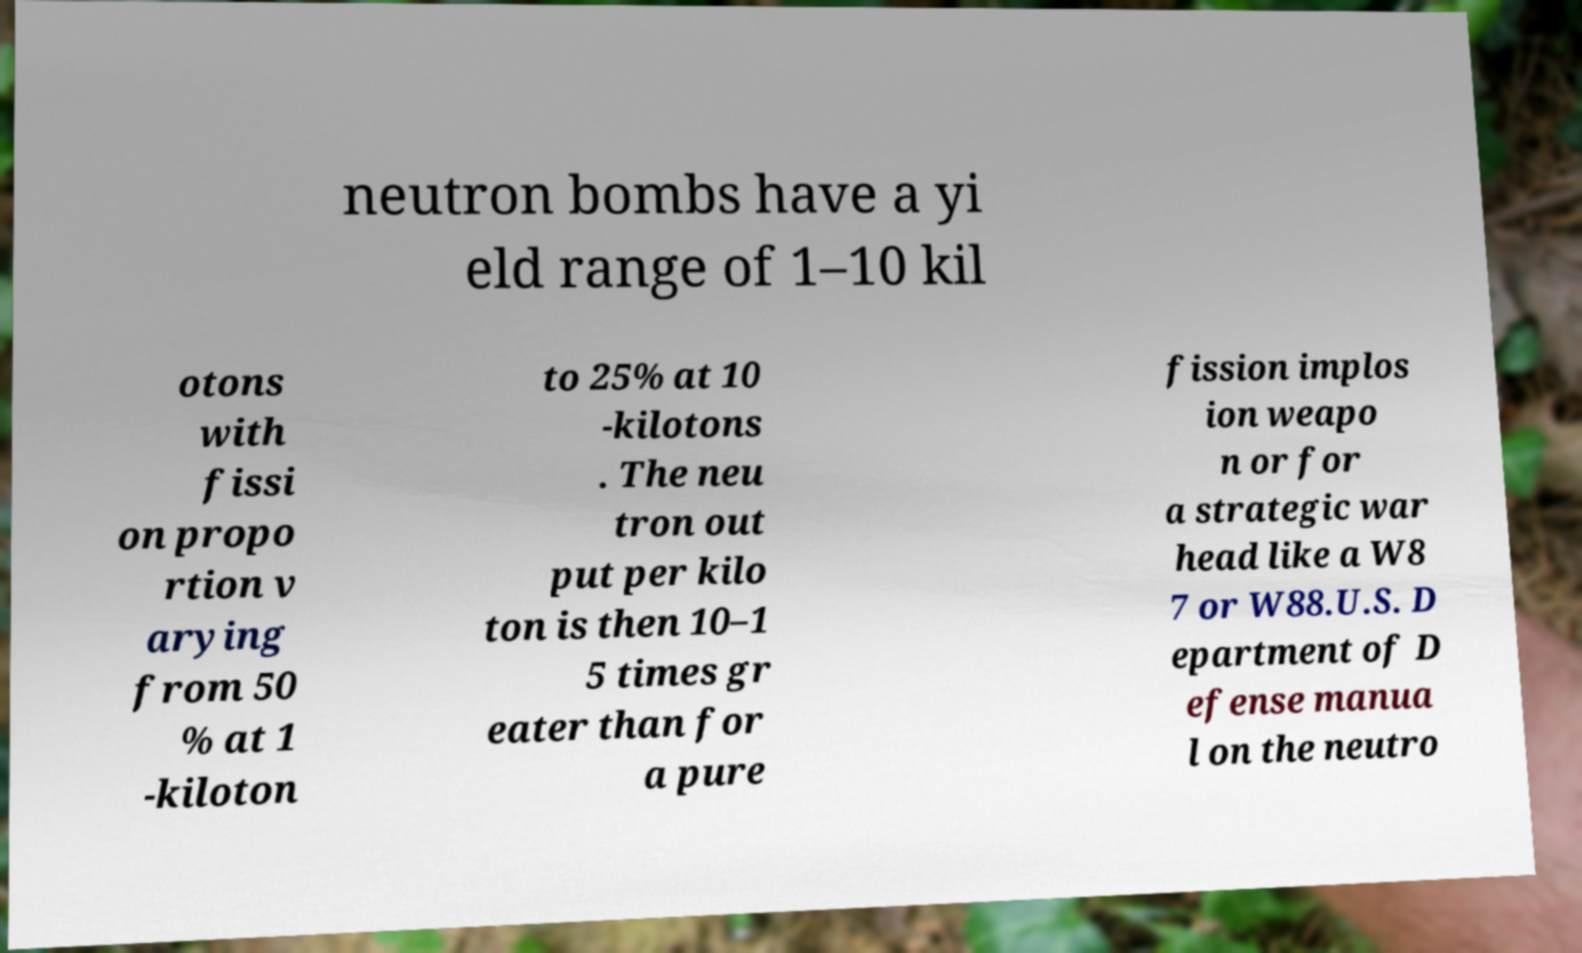Can you read and provide the text displayed in the image?This photo seems to have some interesting text. Can you extract and type it out for me? neutron bombs have a yi eld range of 1–10 kil otons with fissi on propo rtion v arying from 50 % at 1 -kiloton to 25% at 10 -kilotons . The neu tron out put per kilo ton is then 10–1 5 times gr eater than for a pure fission implos ion weapo n or for a strategic war head like a W8 7 or W88.U.S. D epartment of D efense manua l on the neutro 